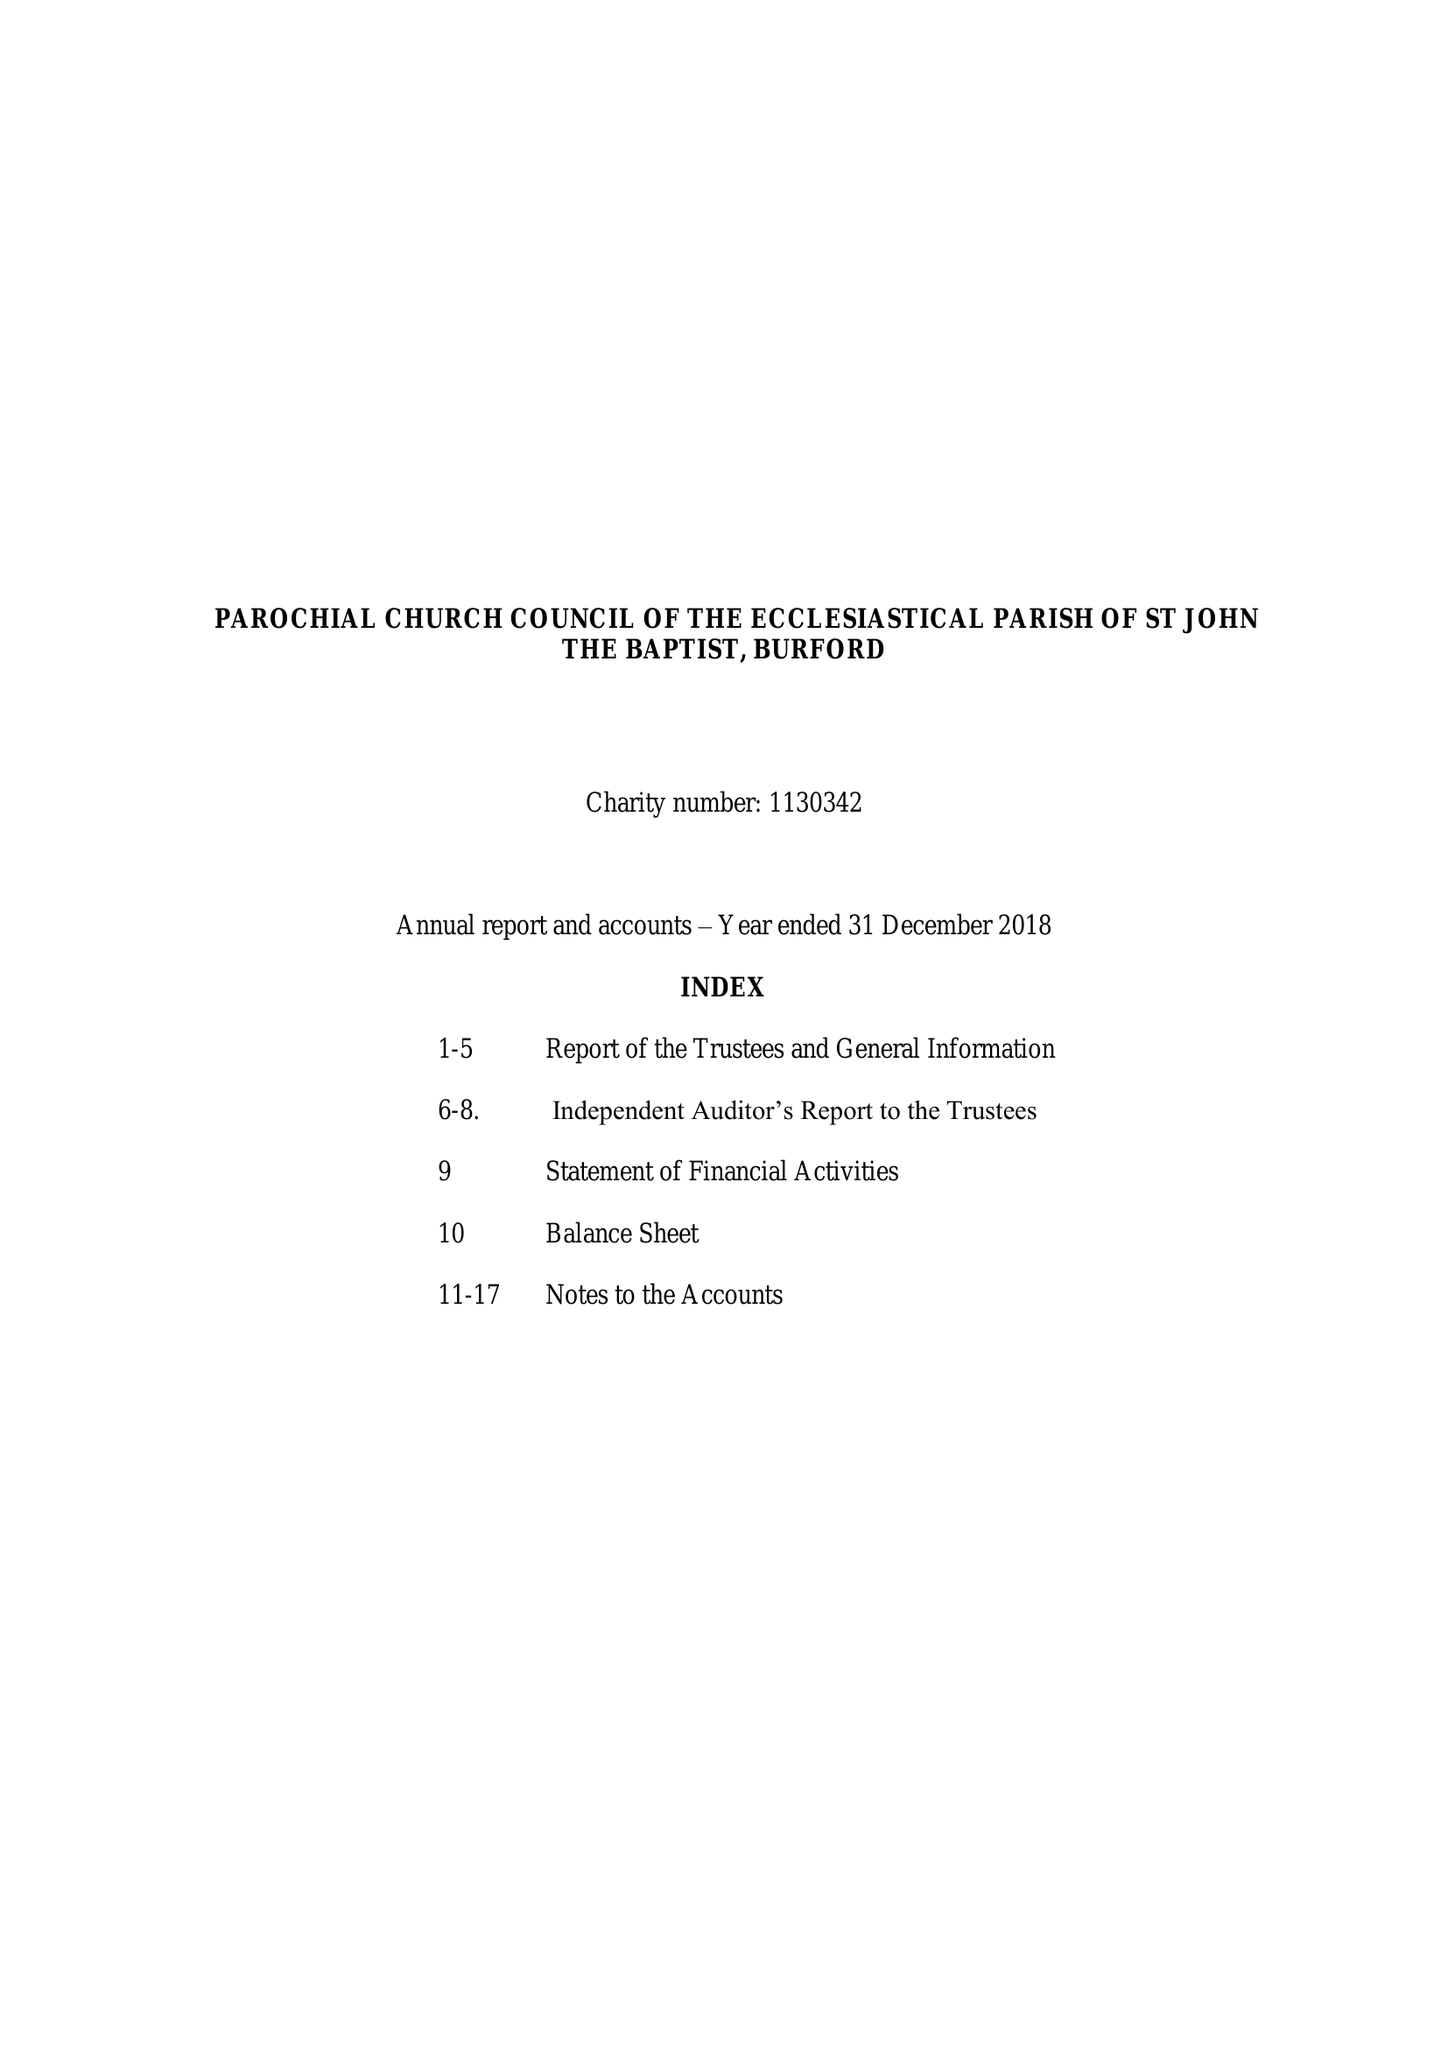What is the value for the address__post_town?
Answer the question using a single word or phrase. CARTERTON 